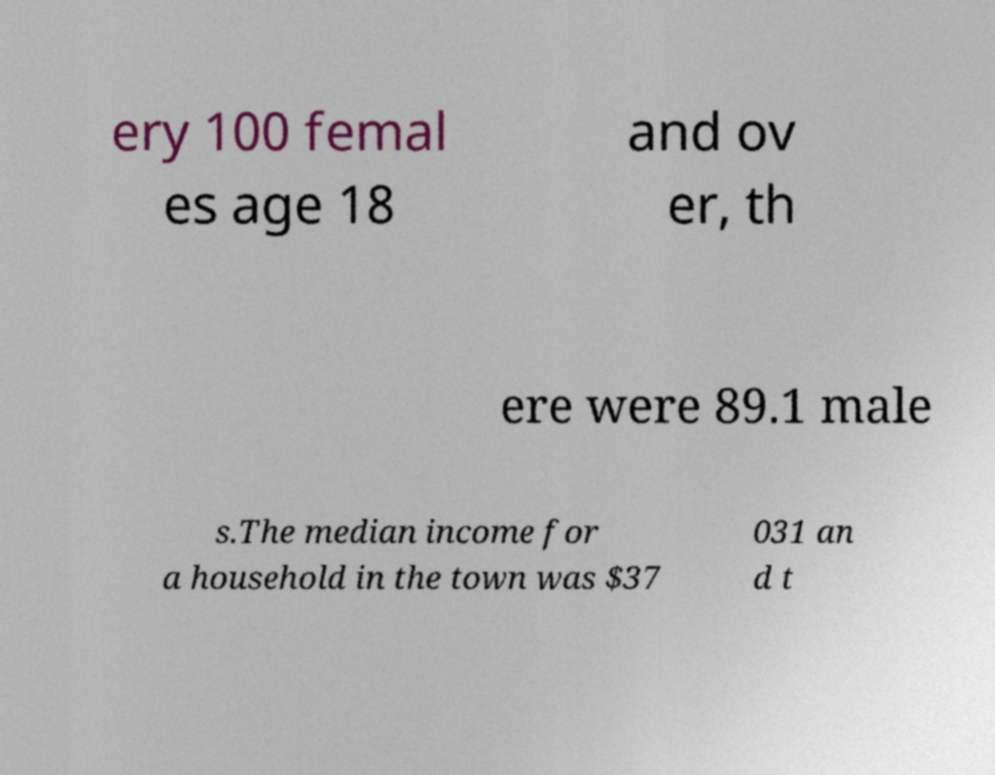Could you extract and type out the text from this image? ery 100 femal es age 18 and ov er, th ere were 89.1 male s.The median income for a household in the town was $37 031 an d t 